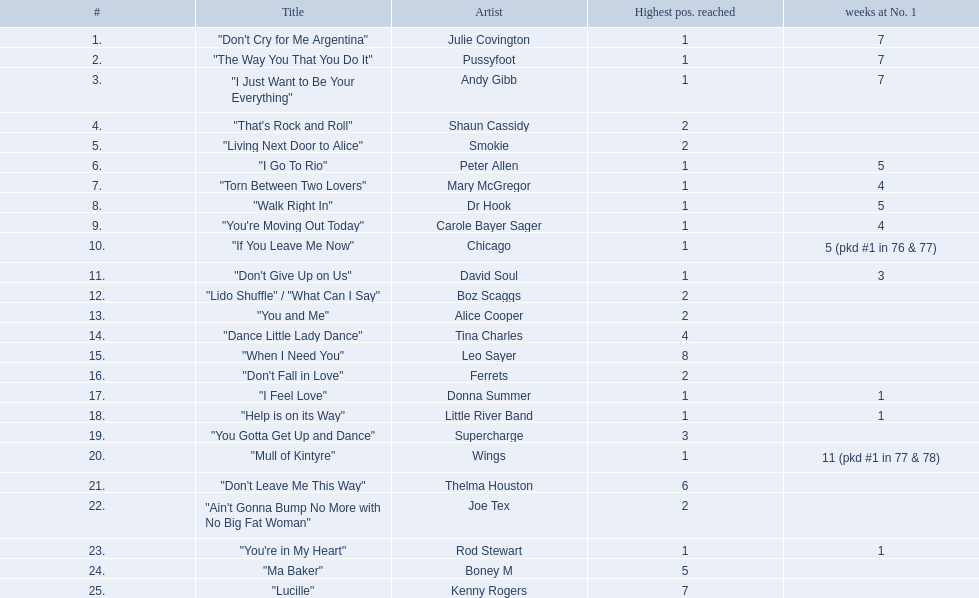Who had one of the lowest durations at the top position? Rod Stewart. Who had zero weeks at the top spot? Shaun Cassidy. Who had the most weeks at the number one ranking? Wings. 